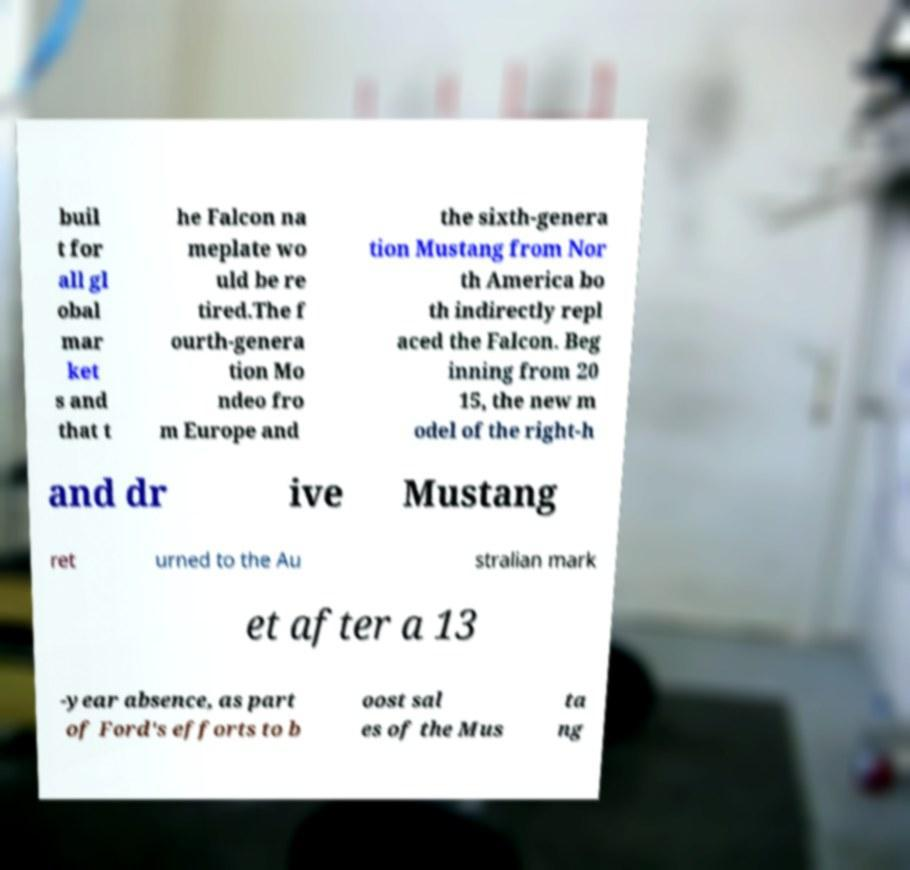Can you read and provide the text displayed in the image?This photo seems to have some interesting text. Can you extract and type it out for me? buil t for all gl obal mar ket s and that t he Falcon na meplate wo uld be re tired.The f ourth-genera tion Mo ndeo fro m Europe and the sixth-genera tion Mustang from Nor th America bo th indirectly repl aced the Falcon. Beg inning from 20 15, the new m odel of the right-h and dr ive Mustang ret urned to the Au stralian mark et after a 13 -year absence, as part of Ford's efforts to b oost sal es of the Mus ta ng 